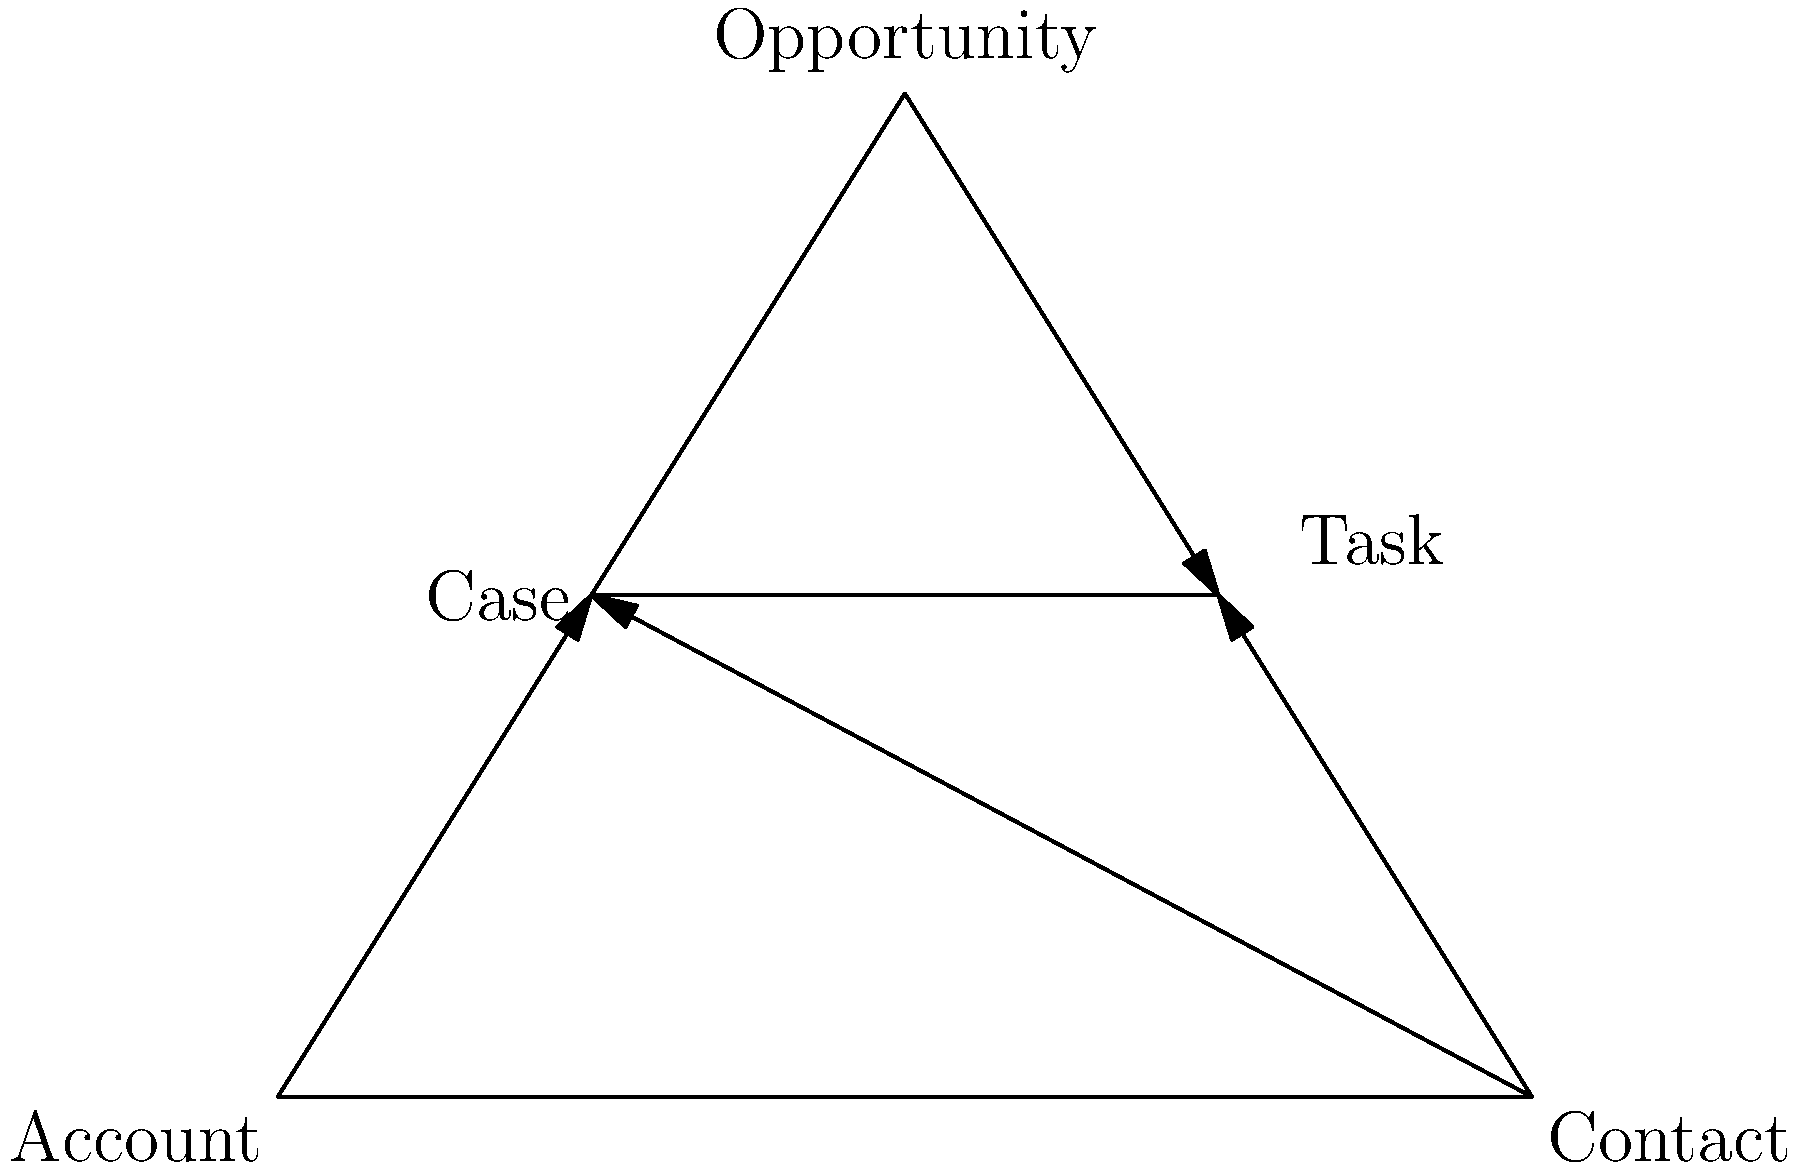Based on the entity-relationship diagram, which Salesforce object appears to have the most relationships, and what type of relationship does it likely have with the other objects? To determine which Salesforce object has the most relationships and the type of relationship it likely has with other objects, let's analyze the diagram step-by-step:

1. Identify the objects in the diagram:
   - Account
   - Contact
   - Opportunity
   - Case
   - Task

2. Count the relationships for each object:
   - Account: 1 relationship (to Case)
   - Contact: 2 relationships (to Case and Task)
   - Opportunity: 1 relationship (to Task)
   - Case: 2 incoming relationships (from Account and Contact)
   - Task: 2 incoming relationships (from Contact and Opportunity)

3. Determine the object with the most relationships:
   Contact has the most relationships, with connections to both Case and Task.

4. Analyze the relationship type:
   The arrows in the diagram point from Contact to both Case and Task. In Salesforce, this typically indicates a parent-child or lookup relationship, where Contact is the parent object and Case and Task are child objects.

5. Interpret the relationship in Salesforce terms:
   This relationship structure suggests that Contact is likely to have a "one-to-many" relationship with both Case and Task. This means that one Contact can be associated with multiple Cases and multiple Tasks.

Based on this analysis, we can conclude that Contact has the most relationships and likely has a one-to-many relationship with Case and Task.
Answer: Contact; one-to-many 